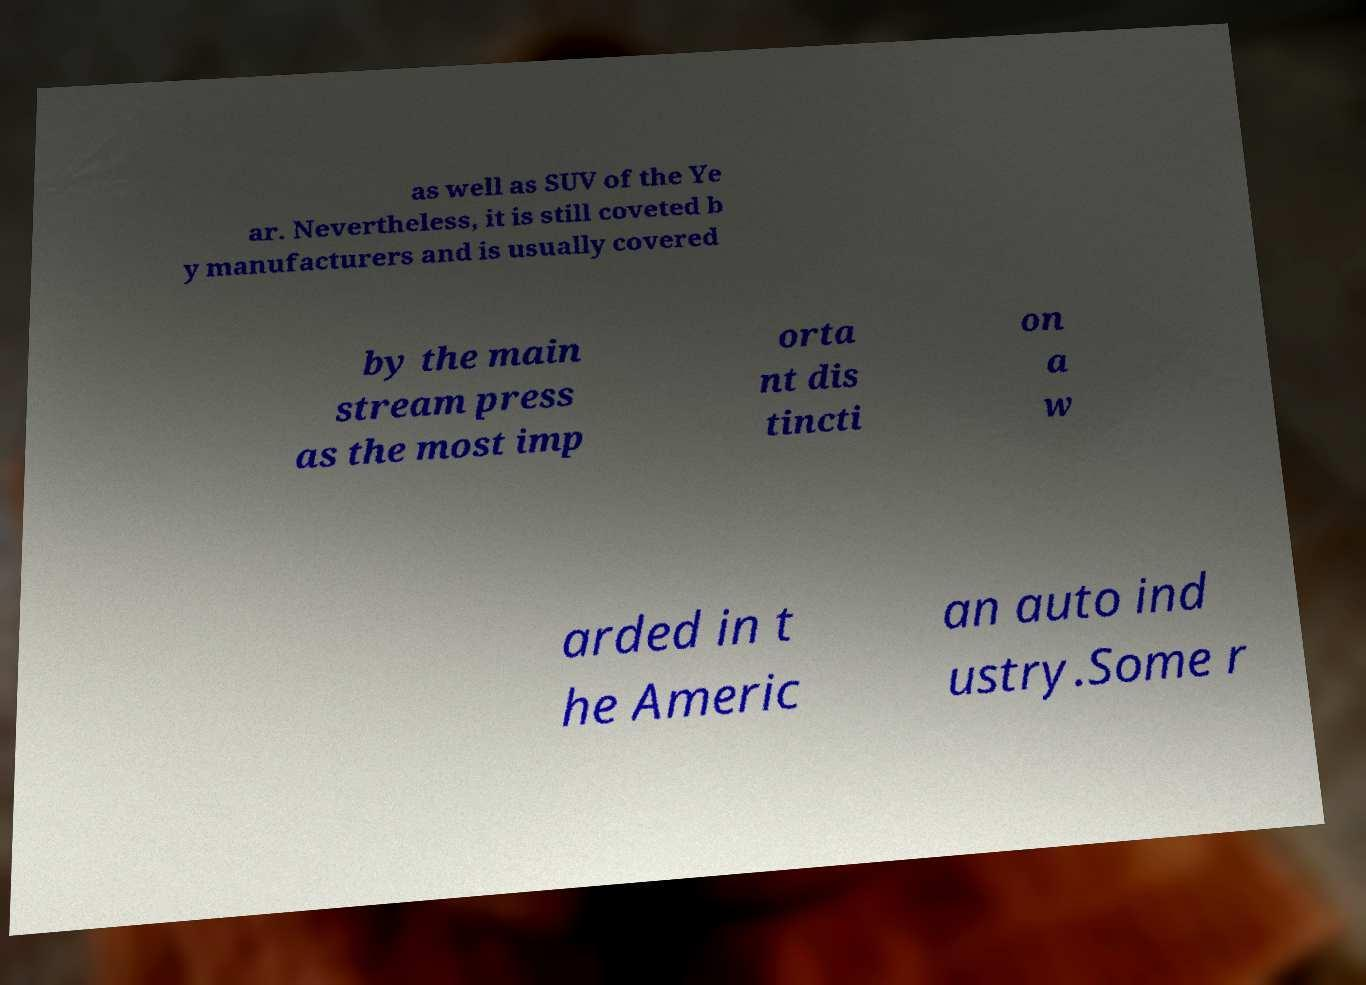For documentation purposes, I need the text within this image transcribed. Could you provide that? as well as SUV of the Ye ar. Nevertheless, it is still coveted b y manufacturers and is usually covered by the main stream press as the most imp orta nt dis tincti on a w arded in t he Americ an auto ind ustry.Some r 